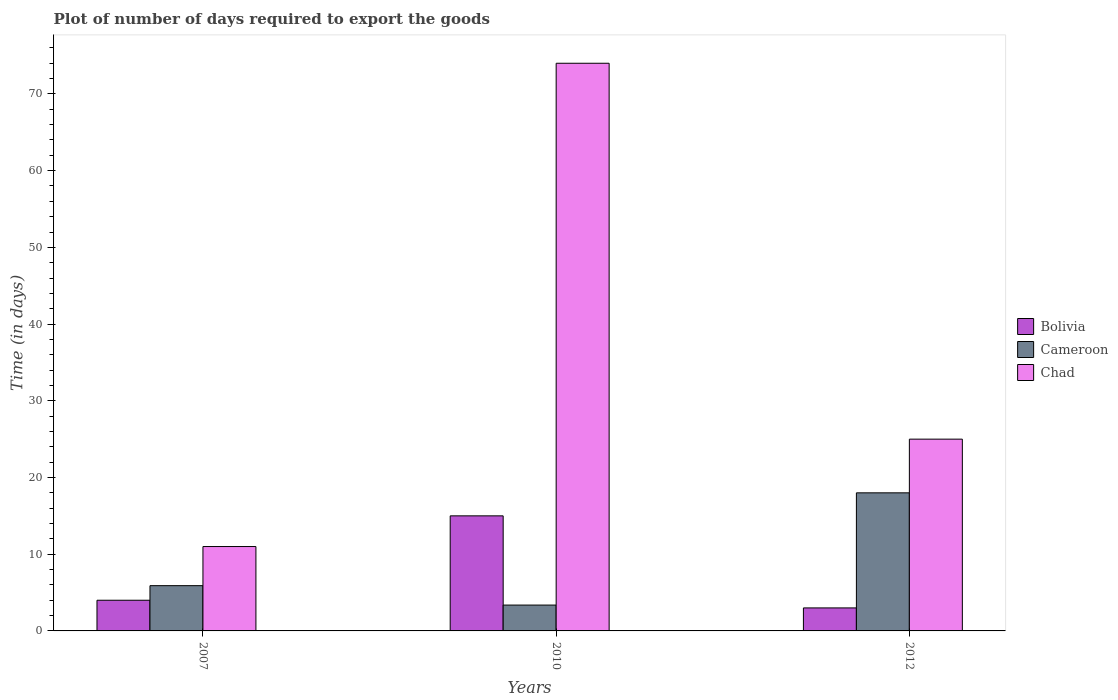How many different coloured bars are there?
Ensure brevity in your answer.  3. How many groups of bars are there?
Keep it short and to the point. 3. How many bars are there on the 3rd tick from the left?
Your response must be concise. 3. How many bars are there on the 1st tick from the right?
Your response must be concise. 3. What is the time required to export goods in Cameroon in 2007?
Provide a succinct answer. 5.9. Across all years, what is the minimum time required to export goods in Chad?
Ensure brevity in your answer.  11. In which year was the time required to export goods in Bolivia minimum?
Ensure brevity in your answer.  2012. What is the total time required to export goods in Chad in the graph?
Your answer should be very brief. 110. What is the difference between the time required to export goods in Bolivia in 2007 and that in 2012?
Your answer should be compact. 1. What is the average time required to export goods in Chad per year?
Give a very brief answer. 36.67. What is the ratio of the time required to export goods in Bolivia in 2007 to that in 2012?
Give a very brief answer. 1.33. Is the difference between the time required to export goods in Chad in 2010 and 2012 greater than the difference between the time required to export goods in Bolivia in 2010 and 2012?
Your answer should be very brief. Yes. What is the difference between the highest and the lowest time required to export goods in Cameroon?
Provide a short and direct response. 14.63. What does the 1st bar from the left in 2007 represents?
Ensure brevity in your answer.  Bolivia. What does the 3rd bar from the right in 2012 represents?
Your answer should be very brief. Bolivia. Is it the case that in every year, the sum of the time required to export goods in Chad and time required to export goods in Bolivia is greater than the time required to export goods in Cameroon?
Provide a short and direct response. Yes. How many bars are there?
Offer a very short reply. 9. How many years are there in the graph?
Keep it short and to the point. 3. What is the difference between two consecutive major ticks on the Y-axis?
Make the answer very short. 10. Are the values on the major ticks of Y-axis written in scientific E-notation?
Ensure brevity in your answer.  No. Does the graph contain any zero values?
Keep it short and to the point. No. How many legend labels are there?
Keep it short and to the point. 3. How are the legend labels stacked?
Your response must be concise. Vertical. What is the title of the graph?
Provide a succinct answer. Plot of number of days required to export the goods. What is the label or title of the Y-axis?
Offer a very short reply. Time (in days). What is the Time (in days) in Bolivia in 2010?
Make the answer very short. 15. What is the Time (in days) in Cameroon in 2010?
Ensure brevity in your answer.  3.37. What is the Time (in days) in Chad in 2010?
Give a very brief answer. 74. Across all years, what is the maximum Time (in days) of Bolivia?
Offer a terse response. 15. Across all years, what is the minimum Time (in days) of Bolivia?
Your answer should be very brief. 3. Across all years, what is the minimum Time (in days) of Cameroon?
Give a very brief answer. 3.37. What is the total Time (in days) of Bolivia in the graph?
Your answer should be very brief. 22. What is the total Time (in days) in Cameroon in the graph?
Offer a terse response. 27.27. What is the total Time (in days) in Chad in the graph?
Your answer should be very brief. 110. What is the difference between the Time (in days) in Bolivia in 2007 and that in 2010?
Your response must be concise. -11. What is the difference between the Time (in days) of Cameroon in 2007 and that in 2010?
Your answer should be very brief. 2.53. What is the difference between the Time (in days) in Chad in 2007 and that in 2010?
Ensure brevity in your answer.  -63. What is the difference between the Time (in days) of Cameroon in 2007 and that in 2012?
Provide a short and direct response. -12.1. What is the difference between the Time (in days) of Bolivia in 2010 and that in 2012?
Provide a short and direct response. 12. What is the difference between the Time (in days) in Cameroon in 2010 and that in 2012?
Make the answer very short. -14.63. What is the difference between the Time (in days) of Chad in 2010 and that in 2012?
Your answer should be very brief. 49. What is the difference between the Time (in days) in Bolivia in 2007 and the Time (in days) in Cameroon in 2010?
Make the answer very short. 0.63. What is the difference between the Time (in days) of Bolivia in 2007 and the Time (in days) of Chad in 2010?
Your answer should be very brief. -70. What is the difference between the Time (in days) in Cameroon in 2007 and the Time (in days) in Chad in 2010?
Ensure brevity in your answer.  -68.1. What is the difference between the Time (in days) in Bolivia in 2007 and the Time (in days) in Cameroon in 2012?
Offer a terse response. -14. What is the difference between the Time (in days) in Bolivia in 2007 and the Time (in days) in Chad in 2012?
Offer a terse response. -21. What is the difference between the Time (in days) of Cameroon in 2007 and the Time (in days) of Chad in 2012?
Your response must be concise. -19.1. What is the difference between the Time (in days) of Bolivia in 2010 and the Time (in days) of Cameroon in 2012?
Offer a very short reply. -3. What is the difference between the Time (in days) of Cameroon in 2010 and the Time (in days) of Chad in 2012?
Make the answer very short. -21.63. What is the average Time (in days) in Bolivia per year?
Give a very brief answer. 7.33. What is the average Time (in days) in Cameroon per year?
Provide a short and direct response. 9.09. What is the average Time (in days) in Chad per year?
Keep it short and to the point. 36.67. In the year 2007, what is the difference between the Time (in days) in Bolivia and Time (in days) in Cameroon?
Provide a succinct answer. -1.9. In the year 2007, what is the difference between the Time (in days) of Bolivia and Time (in days) of Chad?
Keep it short and to the point. -7. In the year 2007, what is the difference between the Time (in days) of Cameroon and Time (in days) of Chad?
Offer a terse response. -5.1. In the year 2010, what is the difference between the Time (in days) of Bolivia and Time (in days) of Cameroon?
Offer a terse response. 11.63. In the year 2010, what is the difference between the Time (in days) of Bolivia and Time (in days) of Chad?
Offer a very short reply. -59. In the year 2010, what is the difference between the Time (in days) in Cameroon and Time (in days) in Chad?
Provide a succinct answer. -70.63. In the year 2012, what is the difference between the Time (in days) in Cameroon and Time (in days) in Chad?
Your response must be concise. -7. What is the ratio of the Time (in days) in Bolivia in 2007 to that in 2010?
Your answer should be compact. 0.27. What is the ratio of the Time (in days) of Cameroon in 2007 to that in 2010?
Provide a short and direct response. 1.75. What is the ratio of the Time (in days) of Chad in 2007 to that in 2010?
Provide a short and direct response. 0.15. What is the ratio of the Time (in days) in Cameroon in 2007 to that in 2012?
Offer a very short reply. 0.33. What is the ratio of the Time (in days) in Chad in 2007 to that in 2012?
Give a very brief answer. 0.44. What is the ratio of the Time (in days) in Cameroon in 2010 to that in 2012?
Make the answer very short. 0.19. What is the ratio of the Time (in days) in Chad in 2010 to that in 2012?
Provide a succinct answer. 2.96. What is the difference between the highest and the second highest Time (in days) of Bolivia?
Give a very brief answer. 11. What is the difference between the highest and the second highest Time (in days) of Cameroon?
Your response must be concise. 12.1. What is the difference between the highest and the lowest Time (in days) in Bolivia?
Ensure brevity in your answer.  12. What is the difference between the highest and the lowest Time (in days) of Cameroon?
Ensure brevity in your answer.  14.63. What is the difference between the highest and the lowest Time (in days) in Chad?
Your answer should be very brief. 63. 